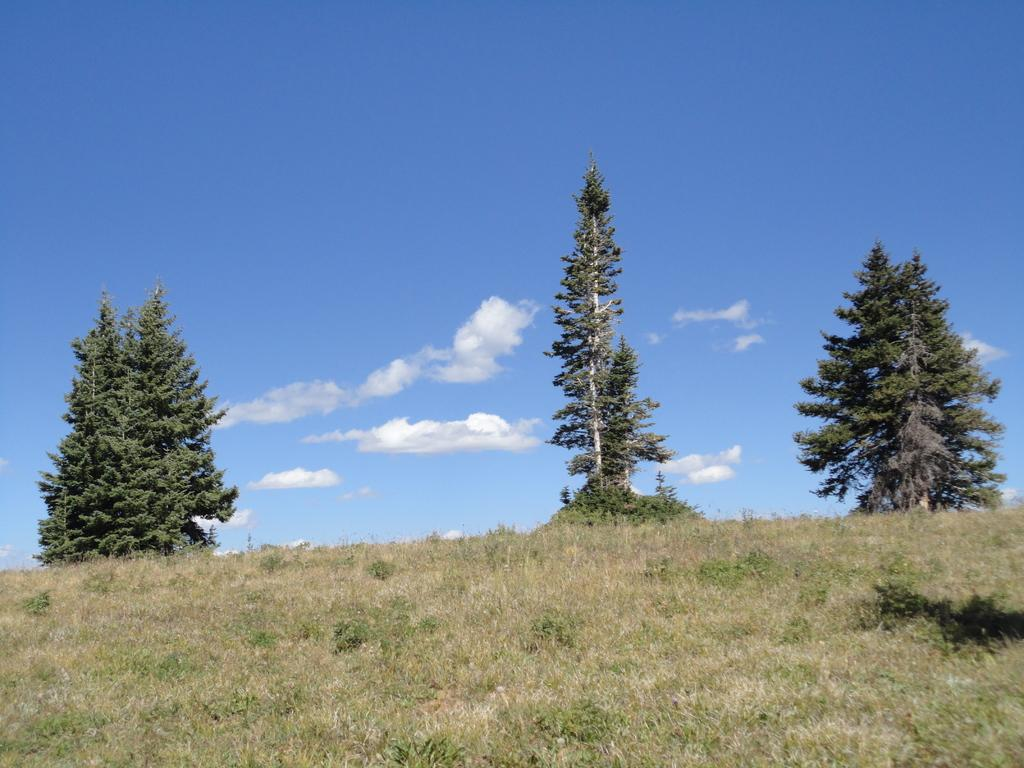What type of vegetation can be seen in the image? There are trees, plants, and grass visible in the image. What part of the natural environment is visible in the image? The sky is visible in the background of the image. What type of apparatus is being used to make a statement in the image? There is no apparatus or statement being made in the image; it features trees, plants, grass, and the sky. What type of bag is visible in the image? There is no bag present in the image. 